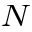<formula> <loc_0><loc_0><loc_500><loc_500>_ { N }</formula> 